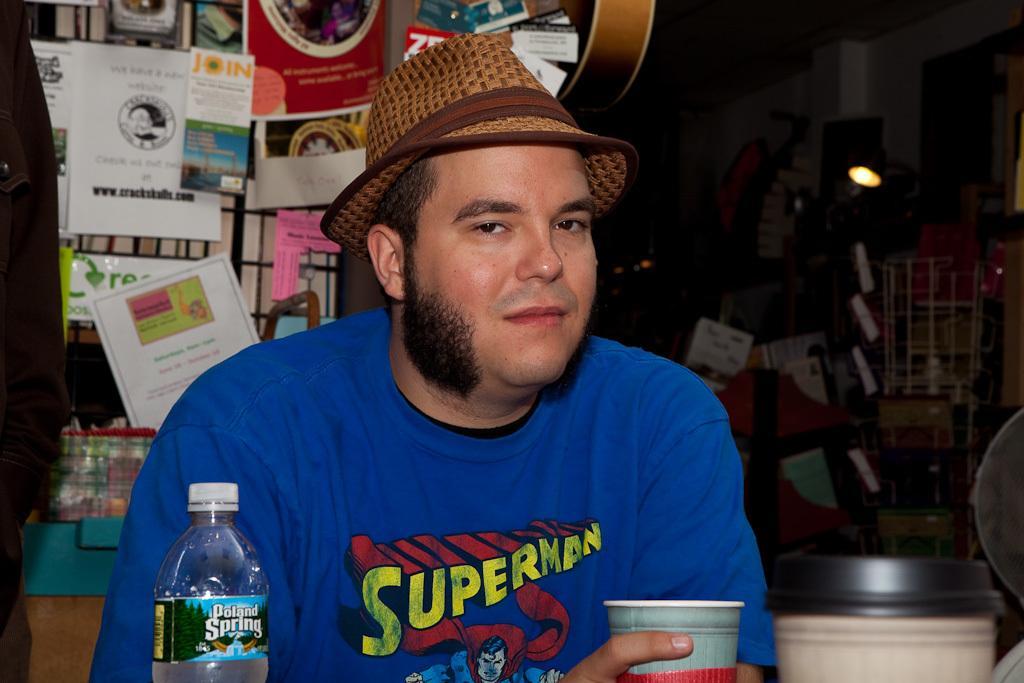Describe this image in one or two sentences. In this image I see a man who is holding a cup and there is a bottle over here and he is also wearing a hat. In the background I see a lot of books and the light over here. 